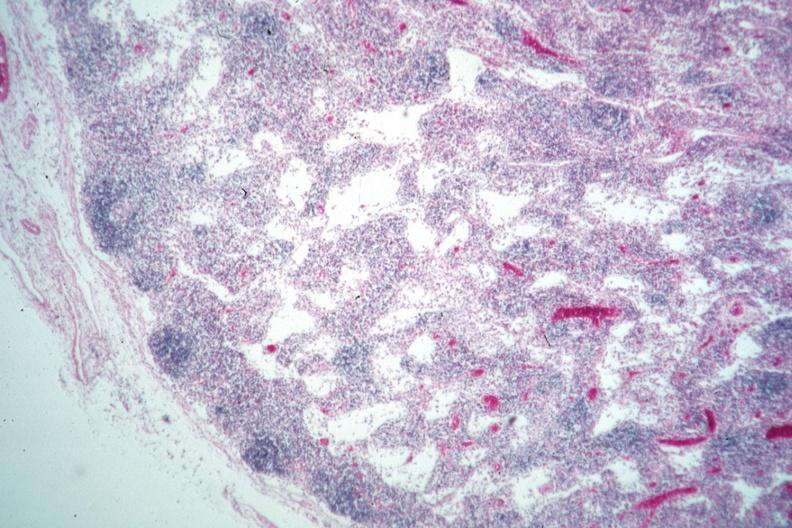s edema present?
Answer the question using a single word or phrase. No 